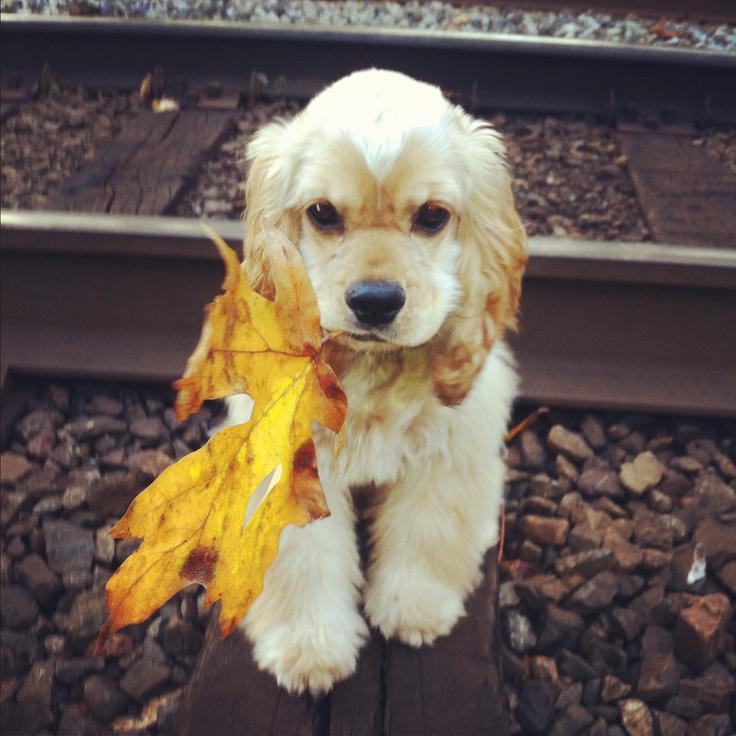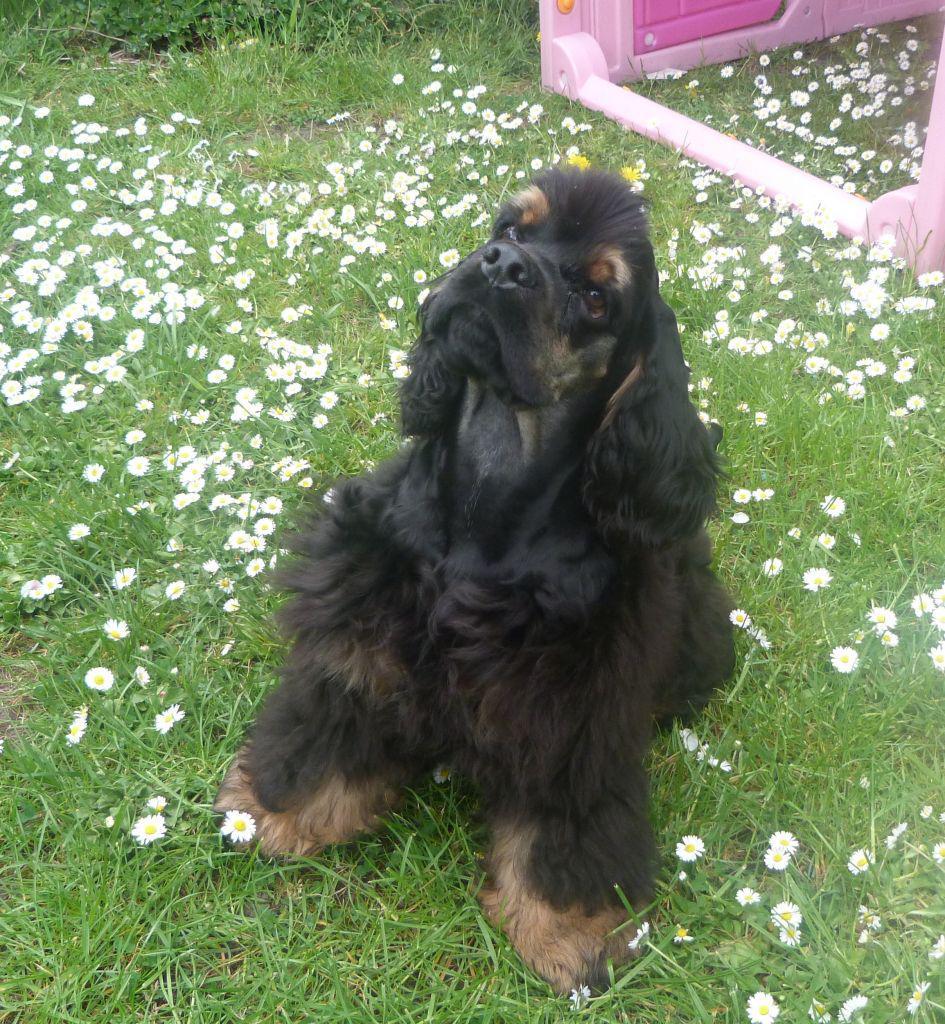The first image is the image on the left, the second image is the image on the right. For the images displayed, is the sentence "In the left image, there's a dog running through the grass while carrying something in its mouth." factually correct? Answer yes or no. No. The first image is the image on the left, the second image is the image on the right. Assess this claim about the two images: "The dog in the right image is lying down on the ground.". Correct or not? Answer yes or no. No. 